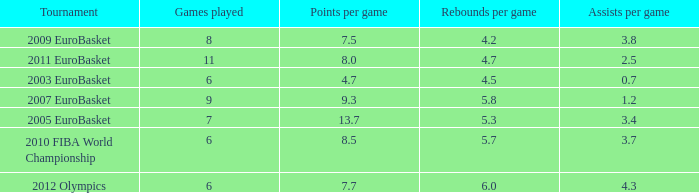How many assists per game have 4.2 rebounds per game? 3.8. 